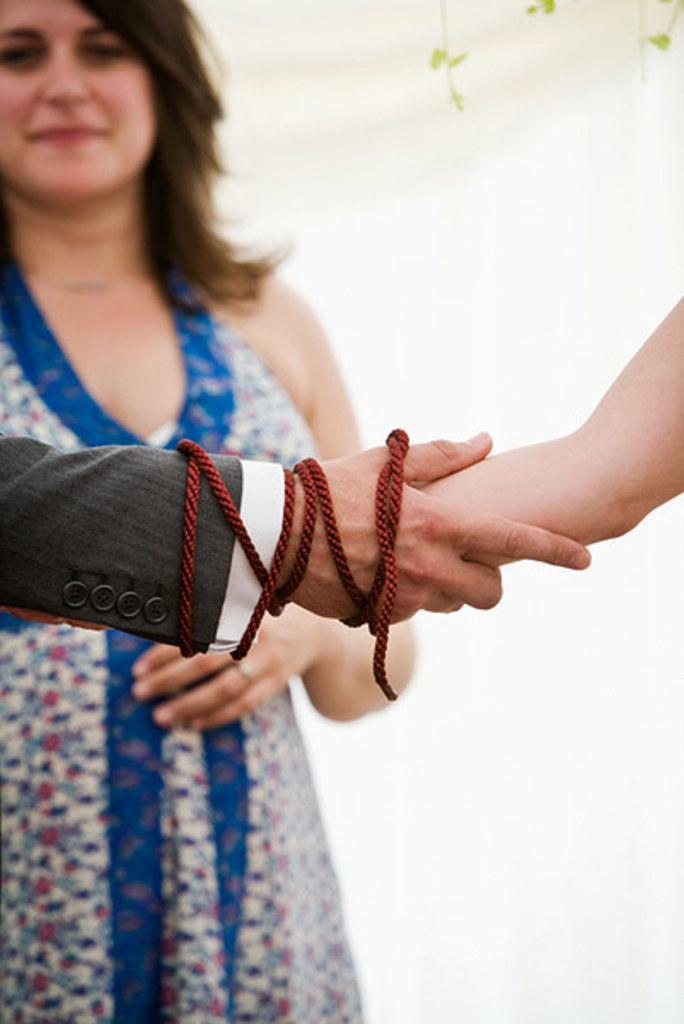Please provide a concise description of this image. In this image we can see a person. In the foreground we can see the person's holding their hands. The background of the image is white. 